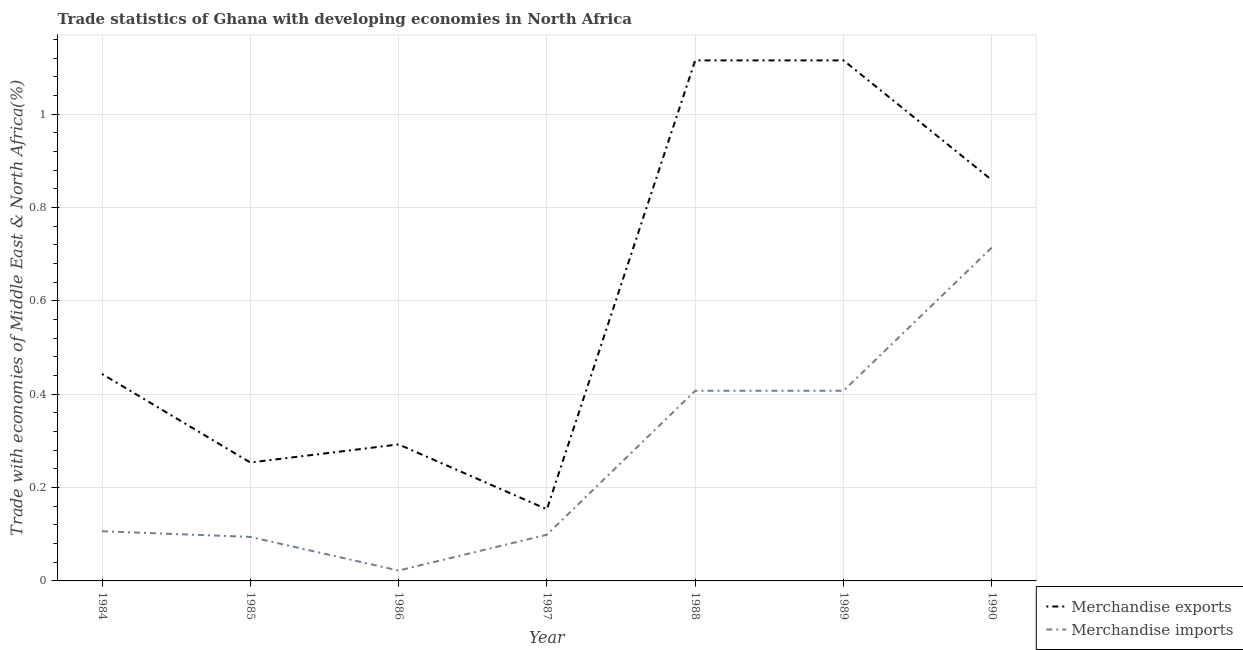Does the line corresponding to merchandise exports intersect with the line corresponding to merchandise imports?
Your answer should be compact. No. Is the number of lines equal to the number of legend labels?
Offer a terse response. Yes. What is the merchandise exports in 1986?
Ensure brevity in your answer.  0.29. Across all years, what is the maximum merchandise imports?
Provide a succinct answer. 0.71. Across all years, what is the minimum merchandise imports?
Your response must be concise. 0.02. In which year was the merchandise exports maximum?
Your answer should be compact. 1989. What is the total merchandise imports in the graph?
Make the answer very short. 1.85. What is the difference between the merchandise imports in 1984 and that in 1990?
Ensure brevity in your answer.  -0.61. What is the difference between the merchandise exports in 1985 and the merchandise imports in 1990?
Make the answer very short. -0.46. What is the average merchandise imports per year?
Make the answer very short. 0.26. In the year 1987, what is the difference between the merchandise exports and merchandise imports?
Offer a very short reply. 0.05. What is the ratio of the merchandise imports in 1986 to that in 1989?
Keep it short and to the point. 0.05. What is the difference between the highest and the second highest merchandise imports?
Your answer should be compact. 0.31. What is the difference between the highest and the lowest merchandise imports?
Keep it short and to the point. 0.69. Does the merchandise exports monotonically increase over the years?
Your response must be concise. No. Is the merchandise imports strictly greater than the merchandise exports over the years?
Your answer should be compact. No. Is the merchandise exports strictly less than the merchandise imports over the years?
Provide a succinct answer. No. How many lines are there?
Your answer should be very brief. 2. How many years are there in the graph?
Provide a short and direct response. 7. What is the difference between two consecutive major ticks on the Y-axis?
Your response must be concise. 0.2. Are the values on the major ticks of Y-axis written in scientific E-notation?
Offer a terse response. No. Does the graph contain any zero values?
Your answer should be compact. No. Does the graph contain grids?
Your answer should be very brief. Yes. Where does the legend appear in the graph?
Your answer should be compact. Bottom right. How many legend labels are there?
Offer a very short reply. 2. What is the title of the graph?
Keep it short and to the point. Trade statistics of Ghana with developing economies in North Africa. What is the label or title of the Y-axis?
Provide a succinct answer. Trade with economies of Middle East & North Africa(%). What is the Trade with economies of Middle East & North Africa(%) in Merchandise exports in 1984?
Your answer should be compact. 0.44. What is the Trade with economies of Middle East & North Africa(%) in Merchandise imports in 1984?
Make the answer very short. 0.11. What is the Trade with economies of Middle East & North Africa(%) of Merchandise exports in 1985?
Provide a short and direct response. 0.25. What is the Trade with economies of Middle East & North Africa(%) of Merchandise imports in 1985?
Your answer should be compact. 0.09. What is the Trade with economies of Middle East & North Africa(%) in Merchandise exports in 1986?
Give a very brief answer. 0.29. What is the Trade with economies of Middle East & North Africa(%) of Merchandise imports in 1986?
Give a very brief answer. 0.02. What is the Trade with economies of Middle East & North Africa(%) in Merchandise exports in 1987?
Make the answer very short. 0.15. What is the Trade with economies of Middle East & North Africa(%) of Merchandise imports in 1987?
Keep it short and to the point. 0.1. What is the Trade with economies of Middle East & North Africa(%) of Merchandise exports in 1988?
Offer a terse response. 1.12. What is the Trade with economies of Middle East & North Africa(%) of Merchandise imports in 1988?
Provide a succinct answer. 0.41. What is the Trade with economies of Middle East & North Africa(%) of Merchandise exports in 1989?
Make the answer very short. 1.12. What is the Trade with economies of Middle East & North Africa(%) of Merchandise imports in 1989?
Keep it short and to the point. 0.41. What is the Trade with economies of Middle East & North Africa(%) of Merchandise exports in 1990?
Your response must be concise. 0.86. What is the Trade with economies of Middle East & North Africa(%) of Merchandise imports in 1990?
Offer a very short reply. 0.71. Across all years, what is the maximum Trade with economies of Middle East & North Africa(%) in Merchandise exports?
Your response must be concise. 1.12. Across all years, what is the maximum Trade with economies of Middle East & North Africa(%) of Merchandise imports?
Provide a short and direct response. 0.71. Across all years, what is the minimum Trade with economies of Middle East & North Africa(%) of Merchandise exports?
Provide a succinct answer. 0.15. Across all years, what is the minimum Trade with economies of Middle East & North Africa(%) in Merchandise imports?
Your response must be concise. 0.02. What is the total Trade with economies of Middle East & North Africa(%) in Merchandise exports in the graph?
Provide a short and direct response. 4.23. What is the total Trade with economies of Middle East & North Africa(%) of Merchandise imports in the graph?
Offer a terse response. 1.85. What is the difference between the Trade with economies of Middle East & North Africa(%) in Merchandise exports in 1984 and that in 1985?
Your answer should be very brief. 0.19. What is the difference between the Trade with economies of Middle East & North Africa(%) in Merchandise imports in 1984 and that in 1985?
Make the answer very short. 0.01. What is the difference between the Trade with economies of Middle East & North Africa(%) of Merchandise exports in 1984 and that in 1986?
Ensure brevity in your answer.  0.15. What is the difference between the Trade with economies of Middle East & North Africa(%) in Merchandise imports in 1984 and that in 1986?
Your response must be concise. 0.08. What is the difference between the Trade with economies of Middle East & North Africa(%) of Merchandise exports in 1984 and that in 1987?
Keep it short and to the point. 0.29. What is the difference between the Trade with economies of Middle East & North Africa(%) of Merchandise imports in 1984 and that in 1987?
Your response must be concise. 0.01. What is the difference between the Trade with economies of Middle East & North Africa(%) of Merchandise exports in 1984 and that in 1988?
Provide a short and direct response. -0.67. What is the difference between the Trade with economies of Middle East & North Africa(%) in Merchandise imports in 1984 and that in 1988?
Provide a succinct answer. -0.3. What is the difference between the Trade with economies of Middle East & North Africa(%) in Merchandise exports in 1984 and that in 1989?
Provide a succinct answer. -0.67. What is the difference between the Trade with economies of Middle East & North Africa(%) in Merchandise imports in 1984 and that in 1989?
Provide a short and direct response. -0.3. What is the difference between the Trade with economies of Middle East & North Africa(%) of Merchandise exports in 1984 and that in 1990?
Offer a terse response. -0.42. What is the difference between the Trade with economies of Middle East & North Africa(%) of Merchandise imports in 1984 and that in 1990?
Your response must be concise. -0.61. What is the difference between the Trade with economies of Middle East & North Africa(%) in Merchandise exports in 1985 and that in 1986?
Your answer should be compact. -0.04. What is the difference between the Trade with economies of Middle East & North Africa(%) of Merchandise imports in 1985 and that in 1986?
Provide a succinct answer. 0.07. What is the difference between the Trade with economies of Middle East & North Africa(%) in Merchandise exports in 1985 and that in 1987?
Give a very brief answer. 0.1. What is the difference between the Trade with economies of Middle East & North Africa(%) of Merchandise imports in 1985 and that in 1987?
Ensure brevity in your answer.  -0. What is the difference between the Trade with economies of Middle East & North Africa(%) of Merchandise exports in 1985 and that in 1988?
Provide a succinct answer. -0.86. What is the difference between the Trade with economies of Middle East & North Africa(%) in Merchandise imports in 1985 and that in 1988?
Keep it short and to the point. -0.31. What is the difference between the Trade with economies of Middle East & North Africa(%) of Merchandise exports in 1985 and that in 1989?
Provide a succinct answer. -0.86. What is the difference between the Trade with economies of Middle East & North Africa(%) in Merchandise imports in 1985 and that in 1989?
Offer a very short reply. -0.31. What is the difference between the Trade with economies of Middle East & North Africa(%) in Merchandise exports in 1985 and that in 1990?
Make the answer very short. -0.61. What is the difference between the Trade with economies of Middle East & North Africa(%) in Merchandise imports in 1985 and that in 1990?
Provide a short and direct response. -0.62. What is the difference between the Trade with economies of Middle East & North Africa(%) in Merchandise exports in 1986 and that in 1987?
Provide a short and direct response. 0.14. What is the difference between the Trade with economies of Middle East & North Africa(%) in Merchandise imports in 1986 and that in 1987?
Your answer should be compact. -0.08. What is the difference between the Trade with economies of Middle East & North Africa(%) of Merchandise exports in 1986 and that in 1988?
Ensure brevity in your answer.  -0.82. What is the difference between the Trade with economies of Middle East & North Africa(%) of Merchandise imports in 1986 and that in 1988?
Your answer should be very brief. -0.39. What is the difference between the Trade with economies of Middle East & North Africa(%) of Merchandise exports in 1986 and that in 1989?
Your answer should be very brief. -0.82. What is the difference between the Trade with economies of Middle East & North Africa(%) in Merchandise imports in 1986 and that in 1989?
Your answer should be very brief. -0.39. What is the difference between the Trade with economies of Middle East & North Africa(%) in Merchandise exports in 1986 and that in 1990?
Your response must be concise. -0.57. What is the difference between the Trade with economies of Middle East & North Africa(%) of Merchandise imports in 1986 and that in 1990?
Provide a short and direct response. -0.69. What is the difference between the Trade with economies of Middle East & North Africa(%) in Merchandise exports in 1987 and that in 1988?
Provide a short and direct response. -0.96. What is the difference between the Trade with economies of Middle East & North Africa(%) in Merchandise imports in 1987 and that in 1988?
Ensure brevity in your answer.  -0.31. What is the difference between the Trade with economies of Middle East & North Africa(%) of Merchandise exports in 1987 and that in 1989?
Ensure brevity in your answer.  -0.96. What is the difference between the Trade with economies of Middle East & North Africa(%) of Merchandise imports in 1987 and that in 1989?
Your answer should be compact. -0.31. What is the difference between the Trade with economies of Middle East & North Africa(%) in Merchandise exports in 1987 and that in 1990?
Keep it short and to the point. -0.71. What is the difference between the Trade with economies of Middle East & North Africa(%) in Merchandise imports in 1987 and that in 1990?
Ensure brevity in your answer.  -0.62. What is the difference between the Trade with economies of Middle East & North Africa(%) of Merchandise imports in 1988 and that in 1989?
Offer a terse response. -0. What is the difference between the Trade with economies of Middle East & North Africa(%) of Merchandise exports in 1988 and that in 1990?
Make the answer very short. 0.26. What is the difference between the Trade with economies of Middle East & North Africa(%) in Merchandise imports in 1988 and that in 1990?
Your answer should be compact. -0.31. What is the difference between the Trade with economies of Middle East & North Africa(%) of Merchandise exports in 1989 and that in 1990?
Your response must be concise. 0.26. What is the difference between the Trade with economies of Middle East & North Africa(%) of Merchandise imports in 1989 and that in 1990?
Offer a terse response. -0.31. What is the difference between the Trade with economies of Middle East & North Africa(%) in Merchandise exports in 1984 and the Trade with economies of Middle East & North Africa(%) in Merchandise imports in 1985?
Make the answer very short. 0.35. What is the difference between the Trade with economies of Middle East & North Africa(%) of Merchandise exports in 1984 and the Trade with economies of Middle East & North Africa(%) of Merchandise imports in 1986?
Provide a short and direct response. 0.42. What is the difference between the Trade with economies of Middle East & North Africa(%) in Merchandise exports in 1984 and the Trade with economies of Middle East & North Africa(%) in Merchandise imports in 1987?
Your answer should be very brief. 0.34. What is the difference between the Trade with economies of Middle East & North Africa(%) of Merchandise exports in 1984 and the Trade with economies of Middle East & North Africa(%) of Merchandise imports in 1988?
Provide a short and direct response. 0.04. What is the difference between the Trade with economies of Middle East & North Africa(%) of Merchandise exports in 1984 and the Trade with economies of Middle East & North Africa(%) of Merchandise imports in 1989?
Your response must be concise. 0.04. What is the difference between the Trade with economies of Middle East & North Africa(%) in Merchandise exports in 1984 and the Trade with economies of Middle East & North Africa(%) in Merchandise imports in 1990?
Keep it short and to the point. -0.27. What is the difference between the Trade with economies of Middle East & North Africa(%) in Merchandise exports in 1985 and the Trade with economies of Middle East & North Africa(%) in Merchandise imports in 1986?
Offer a terse response. 0.23. What is the difference between the Trade with economies of Middle East & North Africa(%) in Merchandise exports in 1985 and the Trade with economies of Middle East & North Africa(%) in Merchandise imports in 1987?
Make the answer very short. 0.15. What is the difference between the Trade with economies of Middle East & North Africa(%) of Merchandise exports in 1985 and the Trade with economies of Middle East & North Africa(%) of Merchandise imports in 1988?
Give a very brief answer. -0.15. What is the difference between the Trade with economies of Middle East & North Africa(%) of Merchandise exports in 1985 and the Trade with economies of Middle East & North Africa(%) of Merchandise imports in 1989?
Make the answer very short. -0.15. What is the difference between the Trade with economies of Middle East & North Africa(%) of Merchandise exports in 1985 and the Trade with economies of Middle East & North Africa(%) of Merchandise imports in 1990?
Keep it short and to the point. -0.46. What is the difference between the Trade with economies of Middle East & North Africa(%) of Merchandise exports in 1986 and the Trade with economies of Middle East & North Africa(%) of Merchandise imports in 1987?
Provide a short and direct response. 0.19. What is the difference between the Trade with economies of Middle East & North Africa(%) in Merchandise exports in 1986 and the Trade with economies of Middle East & North Africa(%) in Merchandise imports in 1988?
Provide a succinct answer. -0.12. What is the difference between the Trade with economies of Middle East & North Africa(%) of Merchandise exports in 1986 and the Trade with economies of Middle East & North Africa(%) of Merchandise imports in 1989?
Provide a succinct answer. -0.12. What is the difference between the Trade with economies of Middle East & North Africa(%) of Merchandise exports in 1986 and the Trade with economies of Middle East & North Africa(%) of Merchandise imports in 1990?
Your answer should be compact. -0.42. What is the difference between the Trade with economies of Middle East & North Africa(%) in Merchandise exports in 1987 and the Trade with economies of Middle East & North Africa(%) in Merchandise imports in 1988?
Offer a terse response. -0.25. What is the difference between the Trade with economies of Middle East & North Africa(%) of Merchandise exports in 1987 and the Trade with economies of Middle East & North Africa(%) of Merchandise imports in 1989?
Offer a terse response. -0.25. What is the difference between the Trade with economies of Middle East & North Africa(%) in Merchandise exports in 1987 and the Trade with economies of Middle East & North Africa(%) in Merchandise imports in 1990?
Give a very brief answer. -0.56. What is the difference between the Trade with economies of Middle East & North Africa(%) in Merchandise exports in 1988 and the Trade with economies of Middle East & North Africa(%) in Merchandise imports in 1989?
Keep it short and to the point. 0.71. What is the difference between the Trade with economies of Middle East & North Africa(%) of Merchandise exports in 1988 and the Trade with economies of Middle East & North Africa(%) of Merchandise imports in 1990?
Offer a terse response. 0.4. What is the difference between the Trade with economies of Middle East & North Africa(%) of Merchandise exports in 1989 and the Trade with economies of Middle East & North Africa(%) of Merchandise imports in 1990?
Provide a short and direct response. 0.4. What is the average Trade with economies of Middle East & North Africa(%) in Merchandise exports per year?
Keep it short and to the point. 0.6. What is the average Trade with economies of Middle East & North Africa(%) in Merchandise imports per year?
Your response must be concise. 0.26. In the year 1984, what is the difference between the Trade with economies of Middle East & North Africa(%) of Merchandise exports and Trade with economies of Middle East & North Africa(%) of Merchandise imports?
Your answer should be very brief. 0.34. In the year 1985, what is the difference between the Trade with economies of Middle East & North Africa(%) in Merchandise exports and Trade with economies of Middle East & North Africa(%) in Merchandise imports?
Your response must be concise. 0.16. In the year 1986, what is the difference between the Trade with economies of Middle East & North Africa(%) of Merchandise exports and Trade with economies of Middle East & North Africa(%) of Merchandise imports?
Provide a short and direct response. 0.27. In the year 1987, what is the difference between the Trade with economies of Middle East & North Africa(%) of Merchandise exports and Trade with economies of Middle East & North Africa(%) of Merchandise imports?
Provide a succinct answer. 0.05. In the year 1988, what is the difference between the Trade with economies of Middle East & North Africa(%) in Merchandise exports and Trade with economies of Middle East & North Africa(%) in Merchandise imports?
Make the answer very short. 0.71. In the year 1989, what is the difference between the Trade with economies of Middle East & North Africa(%) in Merchandise exports and Trade with economies of Middle East & North Africa(%) in Merchandise imports?
Your response must be concise. 0.71. In the year 1990, what is the difference between the Trade with economies of Middle East & North Africa(%) of Merchandise exports and Trade with economies of Middle East & North Africa(%) of Merchandise imports?
Give a very brief answer. 0.14. What is the ratio of the Trade with economies of Middle East & North Africa(%) of Merchandise exports in 1984 to that in 1985?
Offer a very short reply. 1.75. What is the ratio of the Trade with economies of Middle East & North Africa(%) in Merchandise imports in 1984 to that in 1985?
Make the answer very short. 1.13. What is the ratio of the Trade with economies of Middle East & North Africa(%) of Merchandise exports in 1984 to that in 1986?
Give a very brief answer. 1.52. What is the ratio of the Trade with economies of Middle East & North Africa(%) in Merchandise imports in 1984 to that in 1986?
Offer a very short reply. 4.79. What is the ratio of the Trade with economies of Middle East & North Africa(%) in Merchandise exports in 1984 to that in 1987?
Provide a succinct answer. 2.89. What is the ratio of the Trade with economies of Middle East & North Africa(%) in Merchandise imports in 1984 to that in 1987?
Give a very brief answer. 1.07. What is the ratio of the Trade with economies of Middle East & North Africa(%) of Merchandise exports in 1984 to that in 1988?
Give a very brief answer. 0.4. What is the ratio of the Trade with economies of Middle East & North Africa(%) in Merchandise imports in 1984 to that in 1988?
Offer a terse response. 0.26. What is the ratio of the Trade with economies of Middle East & North Africa(%) of Merchandise exports in 1984 to that in 1989?
Offer a terse response. 0.4. What is the ratio of the Trade with economies of Middle East & North Africa(%) of Merchandise imports in 1984 to that in 1989?
Your response must be concise. 0.26. What is the ratio of the Trade with economies of Middle East & North Africa(%) of Merchandise exports in 1984 to that in 1990?
Provide a short and direct response. 0.52. What is the ratio of the Trade with economies of Middle East & North Africa(%) of Merchandise imports in 1984 to that in 1990?
Your answer should be compact. 0.15. What is the ratio of the Trade with economies of Middle East & North Africa(%) in Merchandise exports in 1985 to that in 1986?
Keep it short and to the point. 0.87. What is the ratio of the Trade with economies of Middle East & North Africa(%) in Merchandise imports in 1985 to that in 1986?
Keep it short and to the point. 4.24. What is the ratio of the Trade with economies of Middle East & North Africa(%) of Merchandise exports in 1985 to that in 1987?
Your answer should be very brief. 1.65. What is the ratio of the Trade with economies of Middle East & North Africa(%) in Merchandise imports in 1985 to that in 1987?
Make the answer very short. 0.95. What is the ratio of the Trade with economies of Middle East & North Africa(%) of Merchandise exports in 1985 to that in 1988?
Provide a succinct answer. 0.23. What is the ratio of the Trade with economies of Middle East & North Africa(%) of Merchandise imports in 1985 to that in 1988?
Offer a very short reply. 0.23. What is the ratio of the Trade with economies of Middle East & North Africa(%) in Merchandise exports in 1985 to that in 1989?
Make the answer very short. 0.23. What is the ratio of the Trade with economies of Middle East & North Africa(%) of Merchandise imports in 1985 to that in 1989?
Provide a short and direct response. 0.23. What is the ratio of the Trade with economies of Middle East & North Africa(%) in Merchandise exports in 1985 to that in 1990?
Ensure brevity in your answer.  0.3. What is the ratio of the Trade with economies of Middle East & North Africa(%) of Merchandise imports in 1985 to that in 1990?
Your response must be concise. 0.13. What is the ratio of the Trade with economies of Middle East & North Africa(%) of Merchandise exports in 1986 to that in 1987?
Offer a terse response. 1.9. What is the ratio of the Trade with economies of Middle East & North Africa(%) in Merchandise imports in 1986 to that in 1987?
Offer a terse response. 0.22. What is the ratio of the Trade with economies of Middle East & North Africa(%) of Merchandise exports in 1986 to that in 1988?
Make the answer very short. 0.26. What is the ratio of the Trade with economies of Middle East & North Africa(%) of Merchandise imports in 1986 to that in 1988?
Keep it short and to the point. 0.05. What is the ratio of the Trade with economies of Middle East & North Africa(%) in Merchandise exports in 1986 to that in 1989?
Give a very brief answer. 0.26. What is the ratio of the Trade with economies of Middle East & North Africa(%) of Merchandise imports in 1986 to that in 1989?
Offer a very short reply. 0.05. What is the ratio of the Trade with economies of Middle East & North Africa(%) of Merchandise exports in 1986 to that in 1990?
Your answer should be very brief. 0.34. What is the ratio of the Trade with economies of Middle East & North Africa(%) in Merchandise imports in 1986 to that in 1990?
Your response must be concise. 0.03. What is the ratio of the Trade with economies of Middle East & North Africa(%) of Merchandise exports in 1987 to that in 1988?
Give a very brief answer. 0.14. What is the ratio of the Trade with economies of Middle East & North Africa(%) of Merchandise imports in 1987 to that in 1988?
Provide a short and direct response. 0.24. What is the ratio of the Trade with economies of Middle East & North Africa(%) in Merchandise exports in 1987 to that in 1989?
Your answer should be compact. 0.14. What is the ratio of the Trade with economies of Middle East & North Africa(%) of Merchandise imports in 1987 to that in 1989?
Keep it short and to the point. 0.24. What is the ratio of the Trade with economies of Middle East & North Africa(%) in Merchandise exports in 1987 to that in 1990?
Keep it short and to the point. 0.18. What is the ratio of the Trade with economies of Middle East & North Africa(%) in Merchandise imports in 1987 to that in 1990?
Offer a terse response. 0.14. What is the ratio of the Trade with economies of Middle East & North Africa(%) of Merchandise exports in 1988 to that in 1989?
Offer a terse response. 1. What is the ratio of the Trade with economies of Middle East & North Africa(%) of Merchandise exports in 1988 to that in 1990?
Your answer should be very brief. 1.3. What is the ratio of the Trade with economies of Middle East & North Africa(%) in Merchandise imports in 1988 to that in 1990?
Give a very brief answer. 0.57. What is the ratio of the Trade with economies of Middle East & North Africa(%) of Merchandise exports in 1989 to that in 1990?
Offer a very short reply. 1.3. What is the ratio of the Trade with economies of Middle East & North Africa(%) in Merchandise imports in 1989 to that in 1990?
Your answer should be very brief. 0.57. What is the difference between the highest and the second highest Trade with economies of Middle East & North Africa(%) in Merchandise exports?
Ensure brevity in your answer.  0. What is the difference between the highest and the second highest Trade with economies of Middle East & North Africa(%) in Merchandise imports?
Your response must be concise. 0.31. What is the difference between the highest and the lowest Trade with economies of Middle East & North Africa(%) of Merchandise exports?
Provide a succinct answer. 0.96. What is the difference between the highest and the lowest Trade with economies of Middle East & North Africa(%) in Merchandise imports?
Provide a succinct answer. 0.69. 